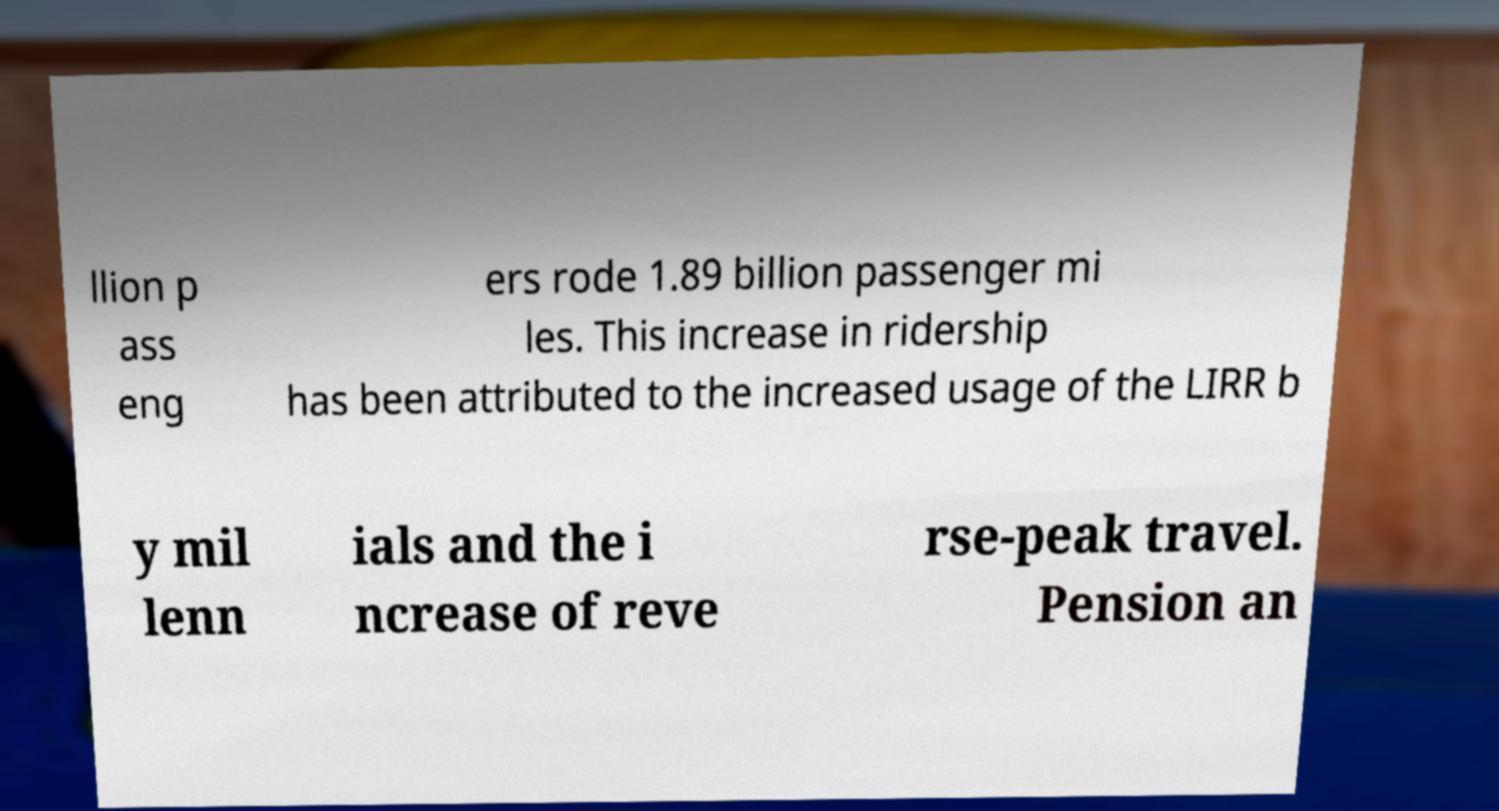I need the written content from this picture converted into text. Can you do that? llion p ass eng ers rode 1.89 billion passenger mi les. This increase in ridership has been attributed to the increased usage of the LIRR b y mil lenn ials and the i ncrease of reve rse-peak travel. Pension an 